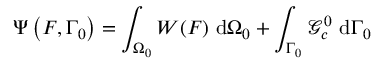<formula> <loc_0><loc_0><loc_500><loc_500>\Psi \left ( F , \Gamma _ { 0 } \right ) = \int _ { \Omega _ { 0 } } W ( F ) \ d \Omega _ { 0 } + \int _ { \Gamma _ { 0 } } \mathcal { G } _ { c } ^ { 0 } \ d \Gamma _ { 0 }</formula> 